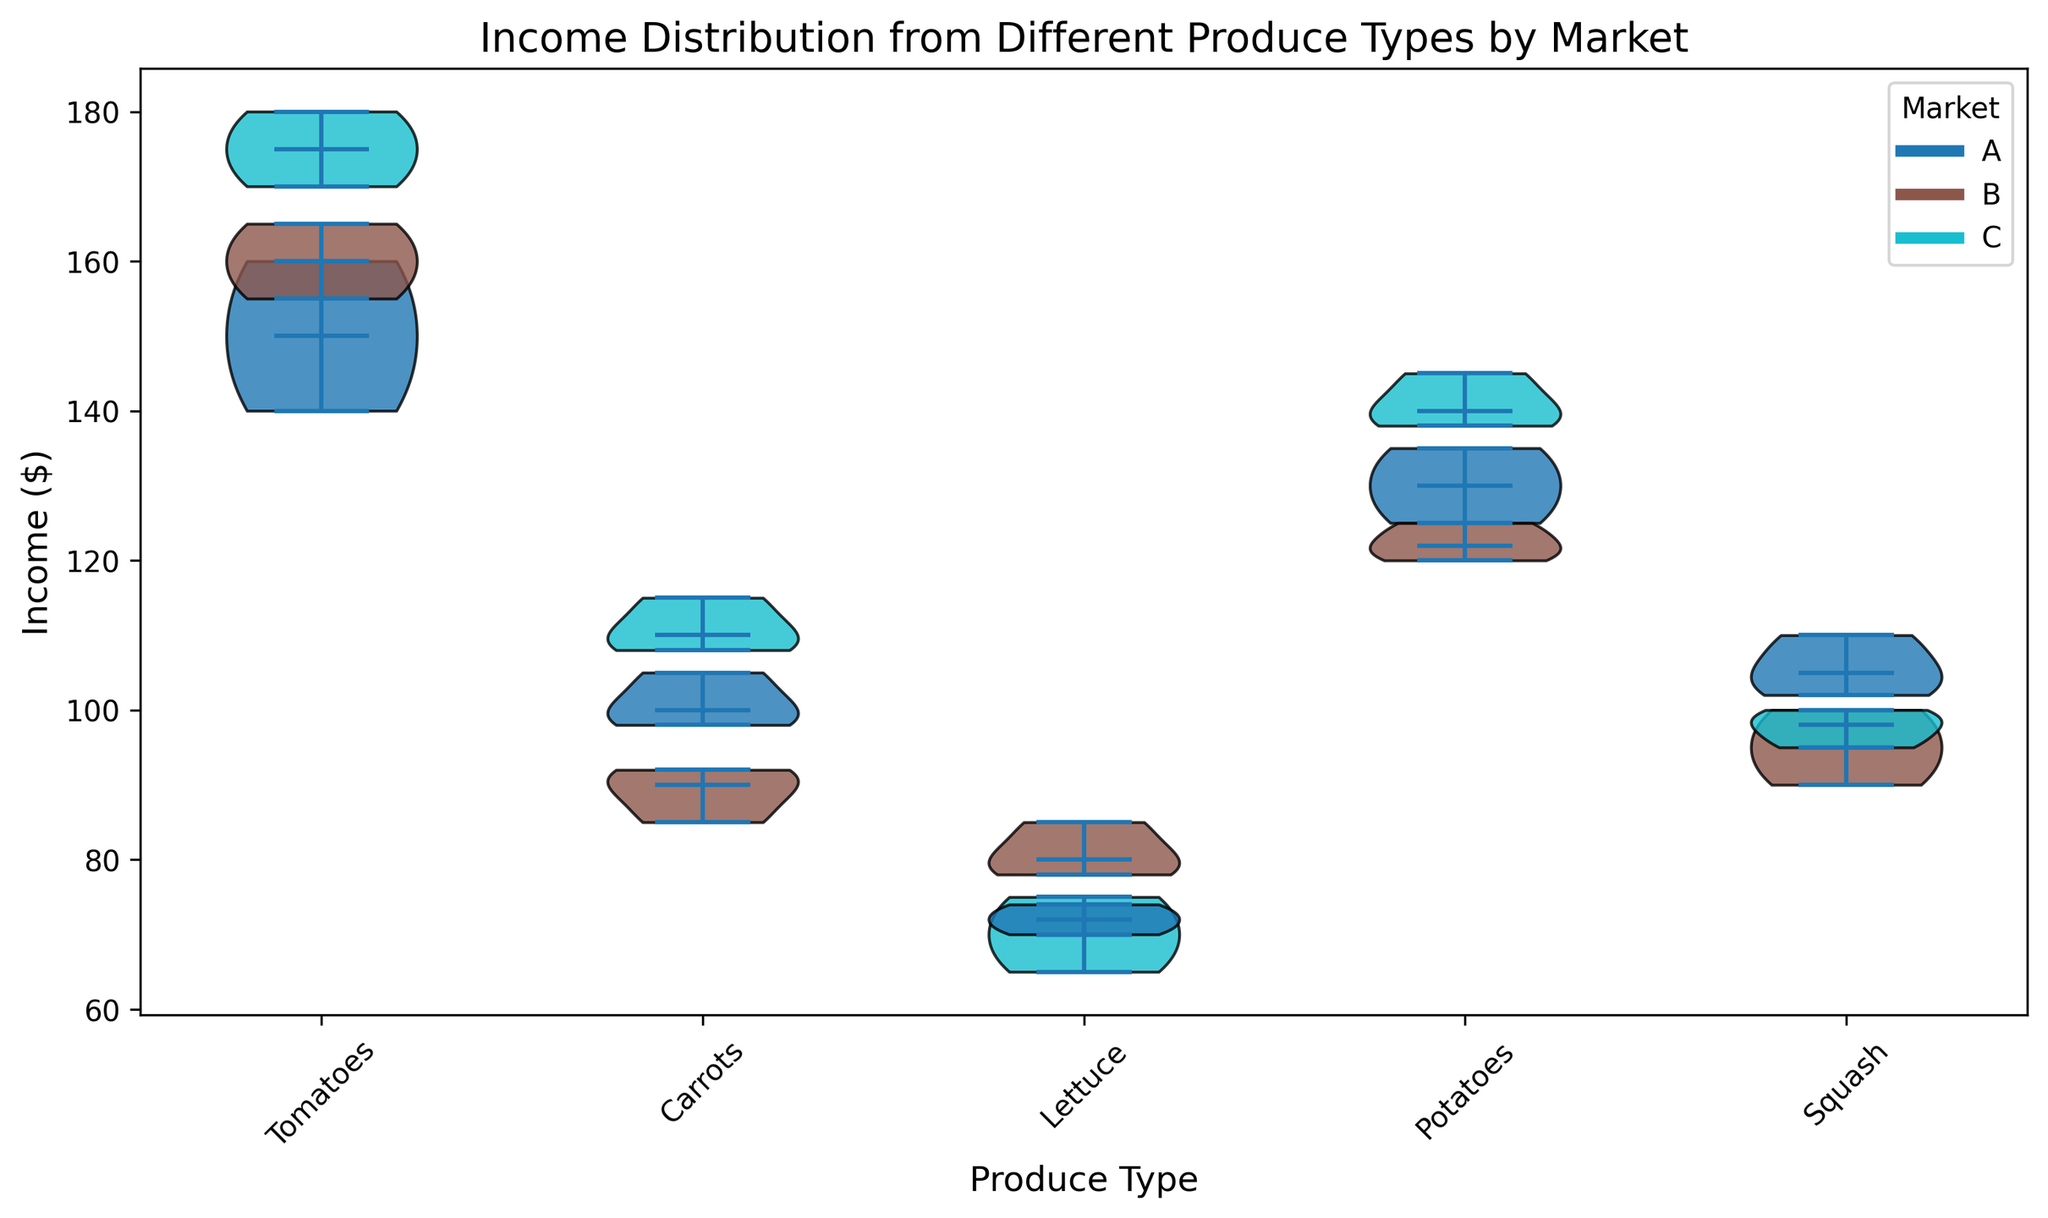How does the median income for tomatoes compare across different markets? The violin plot shows the median income line for each market's distribution of tomatoes. By visually comparing these median lines, we can observe which market has the highest and lowest median incomes for tomatoes.
Answer: Market B has the highest median income, and Market A has the lowest for tomatoes What is the range of income for carrots in Market C? The range can be determined by looking at the spread (height) of the violin plot for carrots in Market C. The top of the plot represents the maximum income, and the bottom represents the minimum income.
Answer: 110 to 115 Which produce type has the highest median income in Market A? To find the produce type with the highest median income in Market A, we look at the median lines of the violin plots for each produce type in Market A. The highest line indicates the highest median income.
Answer: Tomatoes Is the income distribution for lettuce in Market B symmetrical or skewed? The shape of the violin plot indicates the distribution. If the plot is symmetrical around the median line, the distribution is symmetrical. If not, it is skewed.
Answer: Skewed Which market has the largest variation in income for squash? The market with the largest variation will have the widest (tallest) violin plot for squash. By comparing the height of the violin plots for squash across different markets, we can determine this.
Answer: Market B How does the income distribution for tomatoes compare to potatoes in Market C? Comparing the violin plots for tomatoes and potatoes in Market C involves looking at both the median lines and the spread of the distributions. This will show how the central tendency and variability differ.
Answer: Tomatoes have a wider income distribution and a slightly higher median income than potatoes in Market C What is the most consistent income for produce, considering all markets? Consistency can be assessed by the narrowness of the violin plots across all markets. The narrower the plots, the more consistent the income.
Answer: Carrots Are there any produce types whose median income is higher in every market compared to others? By checking the median lines for each produce type across all markets, you can determine if there is any produce type that consistently has a higher median income in every market.
Answer: Tomatoes have higher median incomes in every market compared to lettuce and squash Considering all produce types, which market has the highest overall income distribution? This can be determined by finding which market has the highest median incomes across the majority of the produce types and also considering the spread of their distributions.
Answer: Market B Is there any produce type where Market A generally performs better than other markets? To answer this, compare the median incomes of produce types in Market A with those in Markets B and C. Look for any produce type where Market A's median income is higher than the others.
Answer: No, Market A generally does not outperform other markets in any specific produce type 